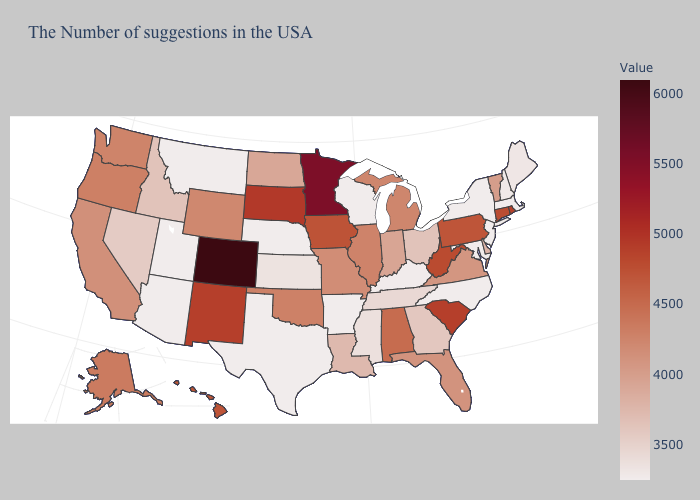Among the states that border West Virginia , does Maryland have the lowest value?
Short answer required. Yes. Among the states that border Texas , does New Mexico have the highest value?
Be succinct. Yes. Does Rhode Island have the highest value in the Northeast?
Concise answer only. Yes. Does Montana have the lowest value in the West?
Keep it brief. Yes. 